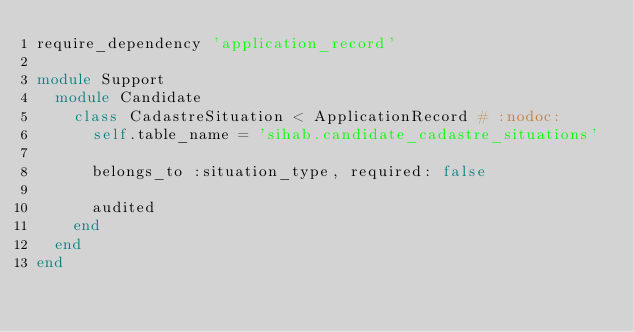Convert code to text. <code><loc_0><loc_0><loc_500><loc_500><_Ruby_>require_dependency 'application_record'

module Support
  module Candidate
    class CadastreSituation < ApplicationRecord # :nodoc:
      self.table_name = 'sihab.candidate_cadastre_situations'

      belongs_to :situation_type, required: false

      audited
    end
  end
end
</code> 